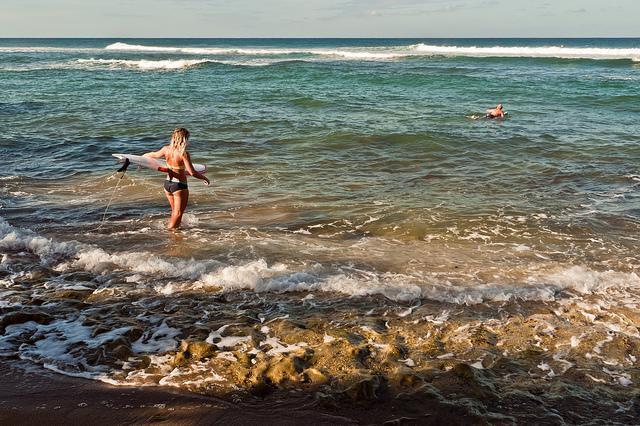How many waves are there?
Give a very brief answer. 3. 